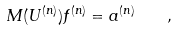Convert formula to latex. <formula><loc_0><loc_0><loc_500><loc_500>M ( U ^ { ( n ) } ) f ^ { ( n ) } = a ^ { ( n ) } \quad ,</formula> 